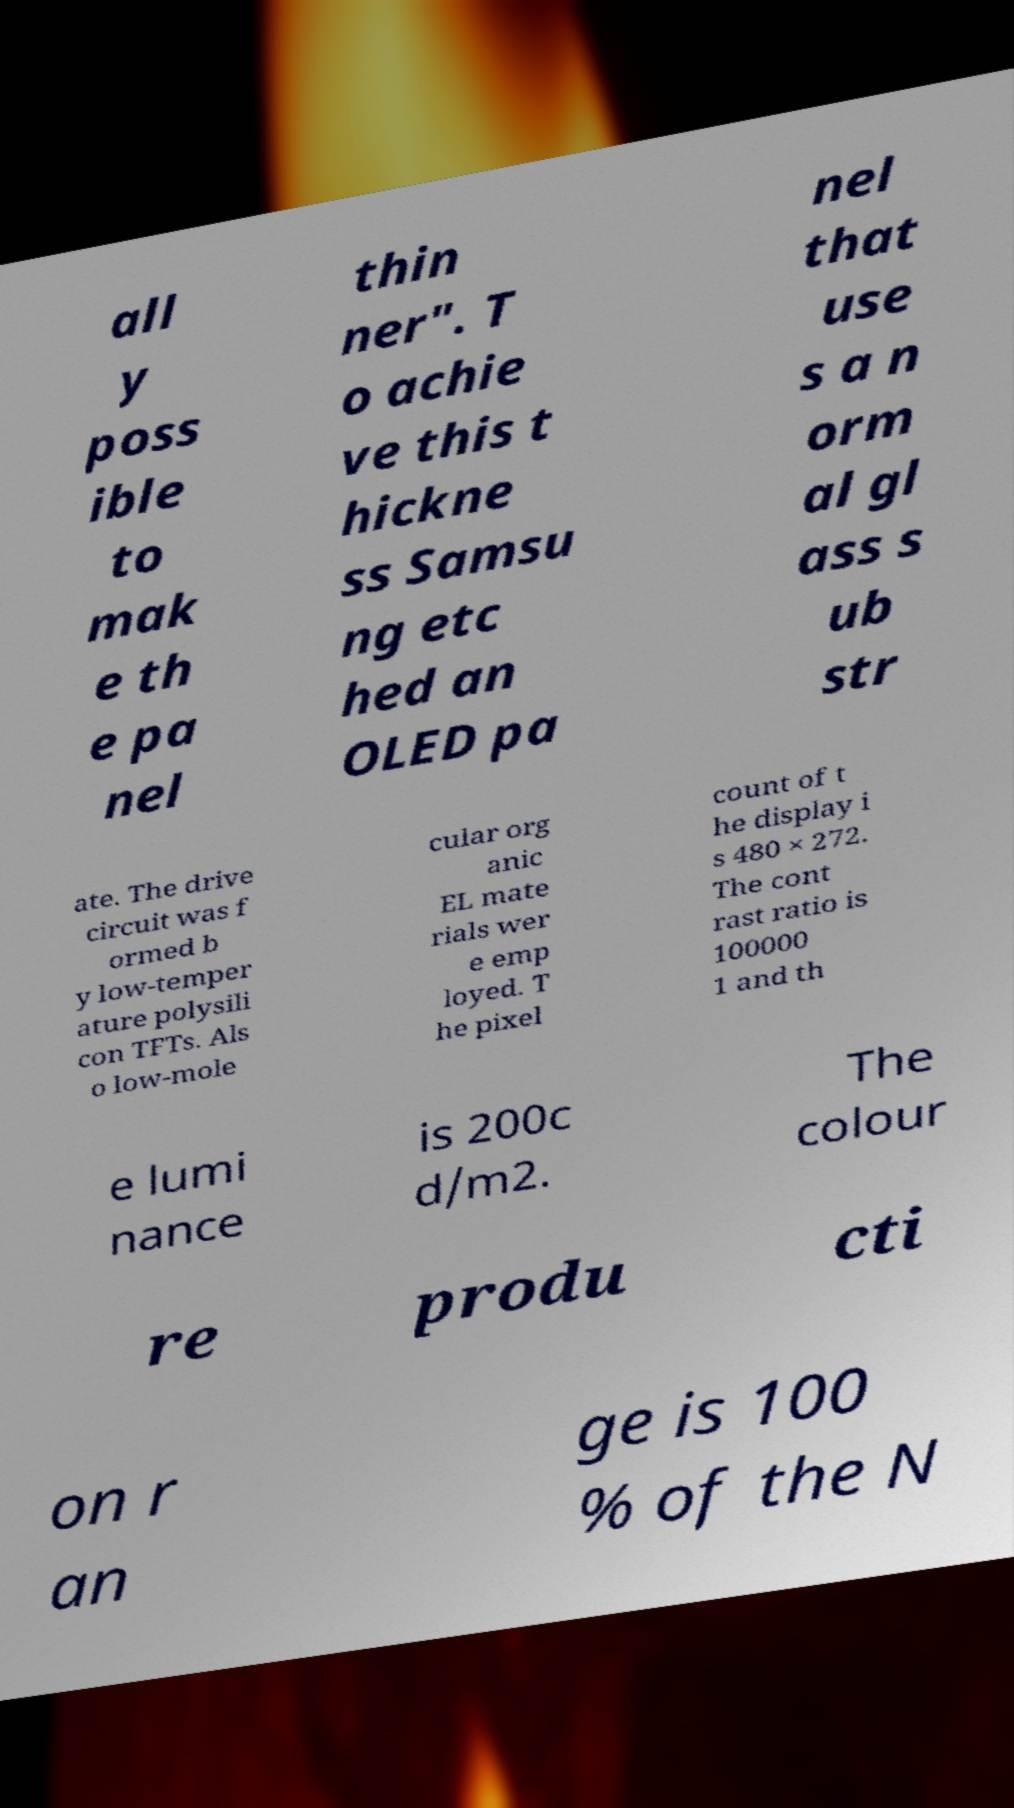Please read and relay the text visible in this image. What does it say? all y poss ible to mak e th e pa nel thin ner". T o achie ve this t hickne ss Samsu ng etc hed an OLED pa nel that use s a n orm al gl ass s ub str ate. The drive circuit was f ormed b y low-temper ature polysili con TFTs. Als o low-mole cular org anic EL mate rials wer e emp loyed. T he pixel count of t he display i s 480 × 272. The cont rast ratio is 100000 1 and th e lumi nance is 200c d/m2. The colour re produ cti on r an ge is 100 % of the N 